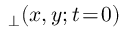Convert formula to latex. <formula><loc_0><loc_0><loc_500><loc_500>_ { \perp } ( x , y ; t \, = \, 0 )</formula> 